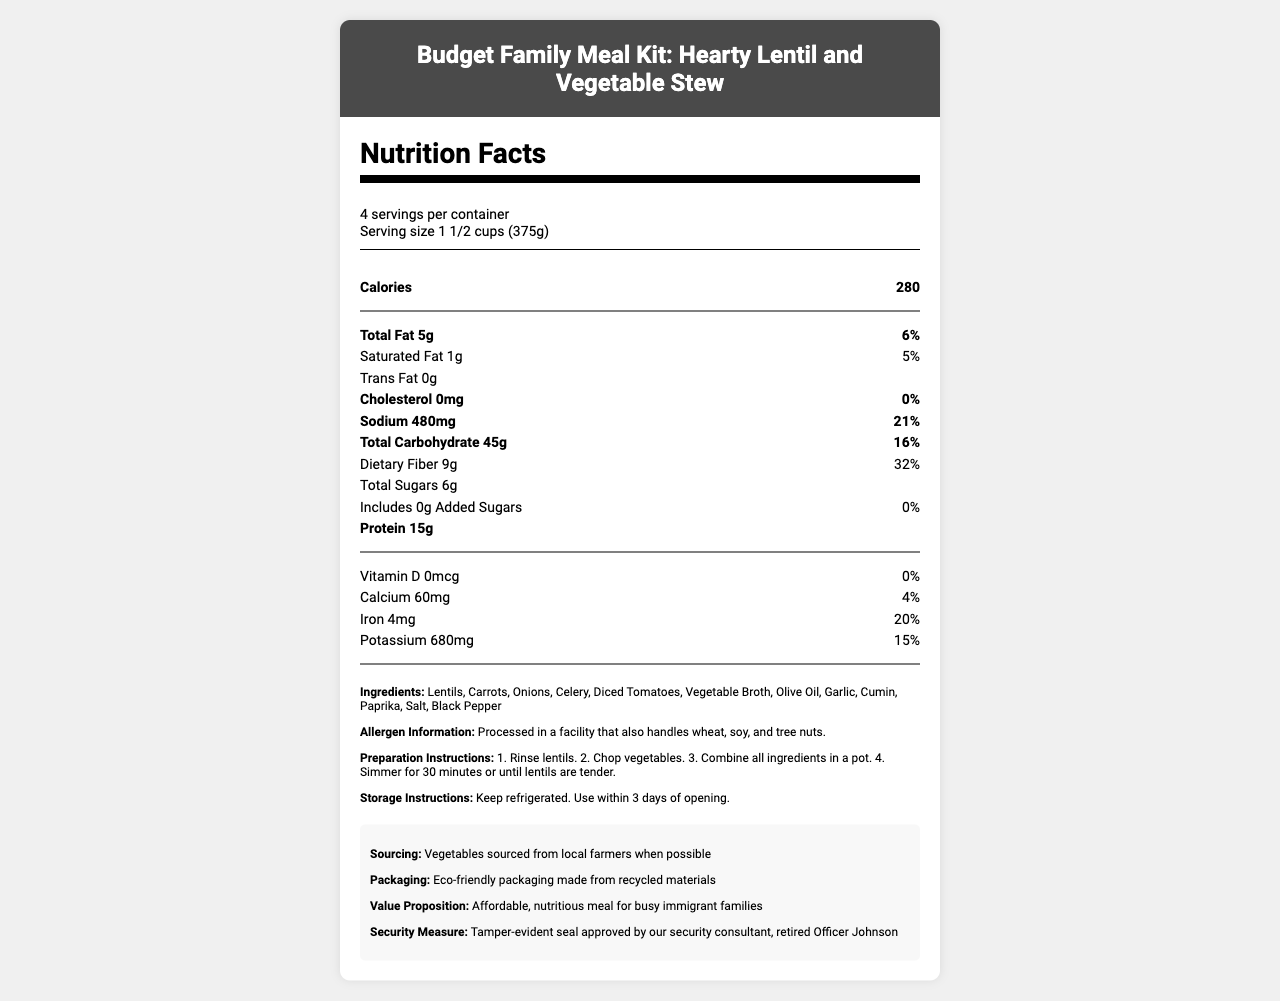what is the serving size of the Budget Family Meal Kit: Hearty Lentil and Vegetable Stew? The serving size is clearly stated at the beginning of the Nutrition Facts section.
Answer: 1 1/2 cups (375g) how many servings are in one container of the meal kit? The document states that there are 4 servings per container.
Answer: 4 what is the calorie count per serving? The number of calories per serving is prominently displayed under the calories section.
Answer: 280 how much protein is there in each serving? The amount of protein per serving is listed as 15g.
Answer: 15g what are the total sugars per serving? The document lists the total sugars per serving as 6g.
Answer: 6g which of the following vitamins or minerals is not present in the meal kit? A. Vitamin D B. Calcium C. Iron D. Potassium The document lists the amount and percent daily value for Vitamin D as 0.
Answer: A. Vitamin D how much dietary fiber does one serving contain? The dietary fiber content per serving is stated as 9g.
Answer: 9g how much sodium is in each serving? The sodium content per serving is listed as 480mg.
Answer: 480mg is this product free of added sugars? The document states that the amount of added sugars is 0g, which means the product is free of added sugars.
Answer: Yes is there any cholesterol in the meal kit? The cholesterol amount is listed as 0mg, and the percent daily value is 0%.
Answer: No which ingredient is listed first in the list? The first ingredient listed is lentils.
Answer: Lentils what precautions should be taken regarding allergens? The allergen information states that the product is processed in a facility that handles these allergens.
Answer: Processed in a facility that also handles wheat, soy, and tree nuts. what local sourcing practice is mentioned in the document? The additional information mentions that vegetables are sourced from local farmers when possible.
Answer: Vegetables sourced from local farmers when possible what are the preparation instructions for the meal kit? The preparation instructions detail the steps needed to prepare the meal kit.
Answer: 1. Rinse lentils. 2. Chop vegetables. 3. Combine all ingredients in a pot. 4. Simmer for 30 minutes or until lentils are tender. what is the meal kit's value proposition? The document mentions that the meal kit is designed to be an affordable and nutritious meal for busy immigrant families.
Answer: Affordable, nutritious meal for busy immigrant families how should the meal kit be stored? The storage instructions specify to keep the meal kit refrigerated and use it within 3 days of opening.
Answer: Keep refrigerated. Use within 3 days of opening. how much iron is in each serving? Each serving contains 4mg of iron, as listed in the document.
Answer: 4mg who has approved the tamper-evident seal as a security measure? The additional information lists retired Officer Johnson as the person who approved the tamper-evident seal.
Answer: Retired Officer Johnson what eco-friendly aspect of the packaging is mentioned? The additional information mentions that the packaging is made from recycled materials.
Answer: Eco-friendly packaging made from recycled materials describe the main idea of the document. The document covers all aspects of the meal kit, including nutritional facts, ingredient details, preparation methods, storage instructions, and additional info like value proposition, eco-friendly measures, and security.
Answer: The document provides detailed nutritional information, ingredient list, and preparation and storage instructions for the Budget Family Meal Kit: Hearty Lentil and Vegetable Stew. Additionally, it highlights the product's value proposition, allergen information, eco-friendly packaging, local sourcing of vegetables, and security measures. can this product help with a keto diet? The document does not provide information specific to dietary programs like the keto diet.
Answer: Cannot be determined 